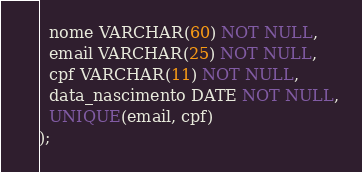Convert code to text. <code><loc_0><loc_0><loc_500><loc_500><_SQL_>  nome VARCHAR(60) NOT NULL,
  email VARCHAR(25) NOT NULL,
  cpf VARCHAR(11) NOT NULL,
  data_nascimento DATE NOT NULL,
  UNIQUE(email, cpf)
);</code> 